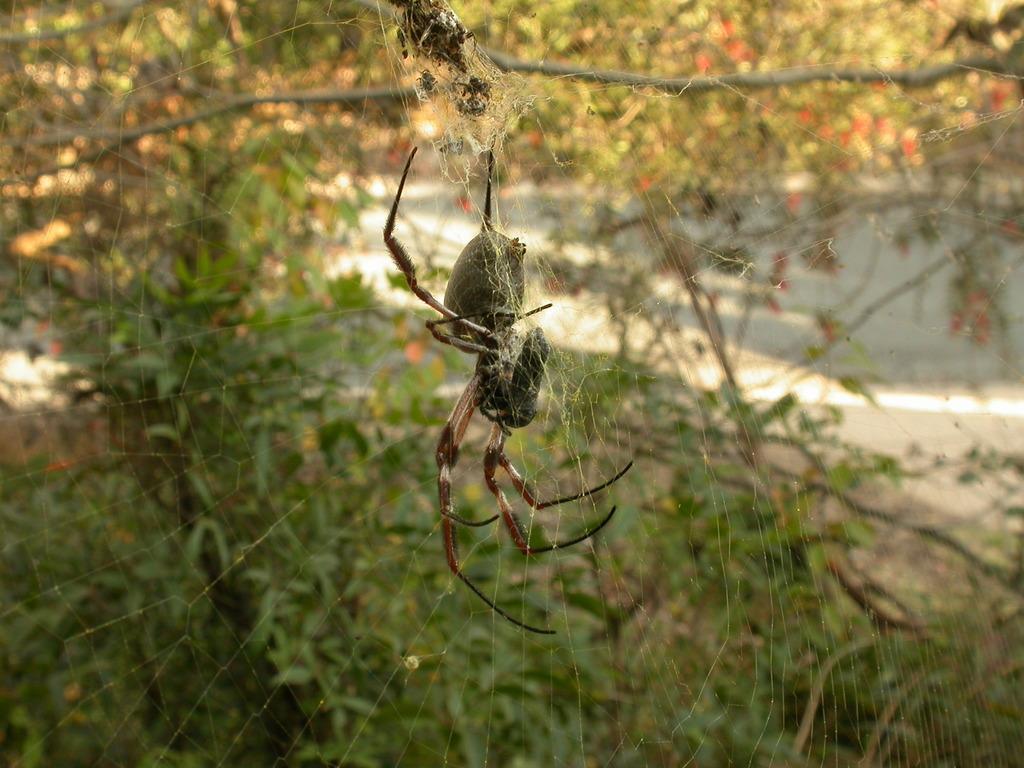Please provide a concise description of this image. There is a spider on the web. In the background, there are trees, plants and there is ground. 